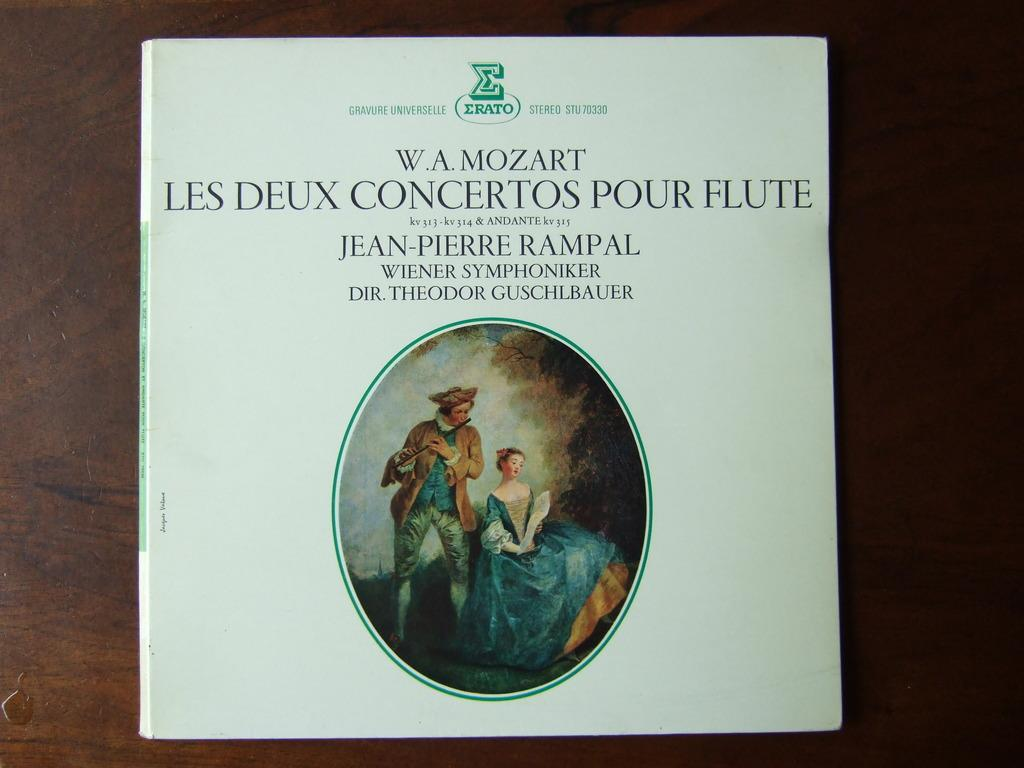<image>
Relay a brief, clear account of the picture shown. A book about Mozart's music sits on a table. 